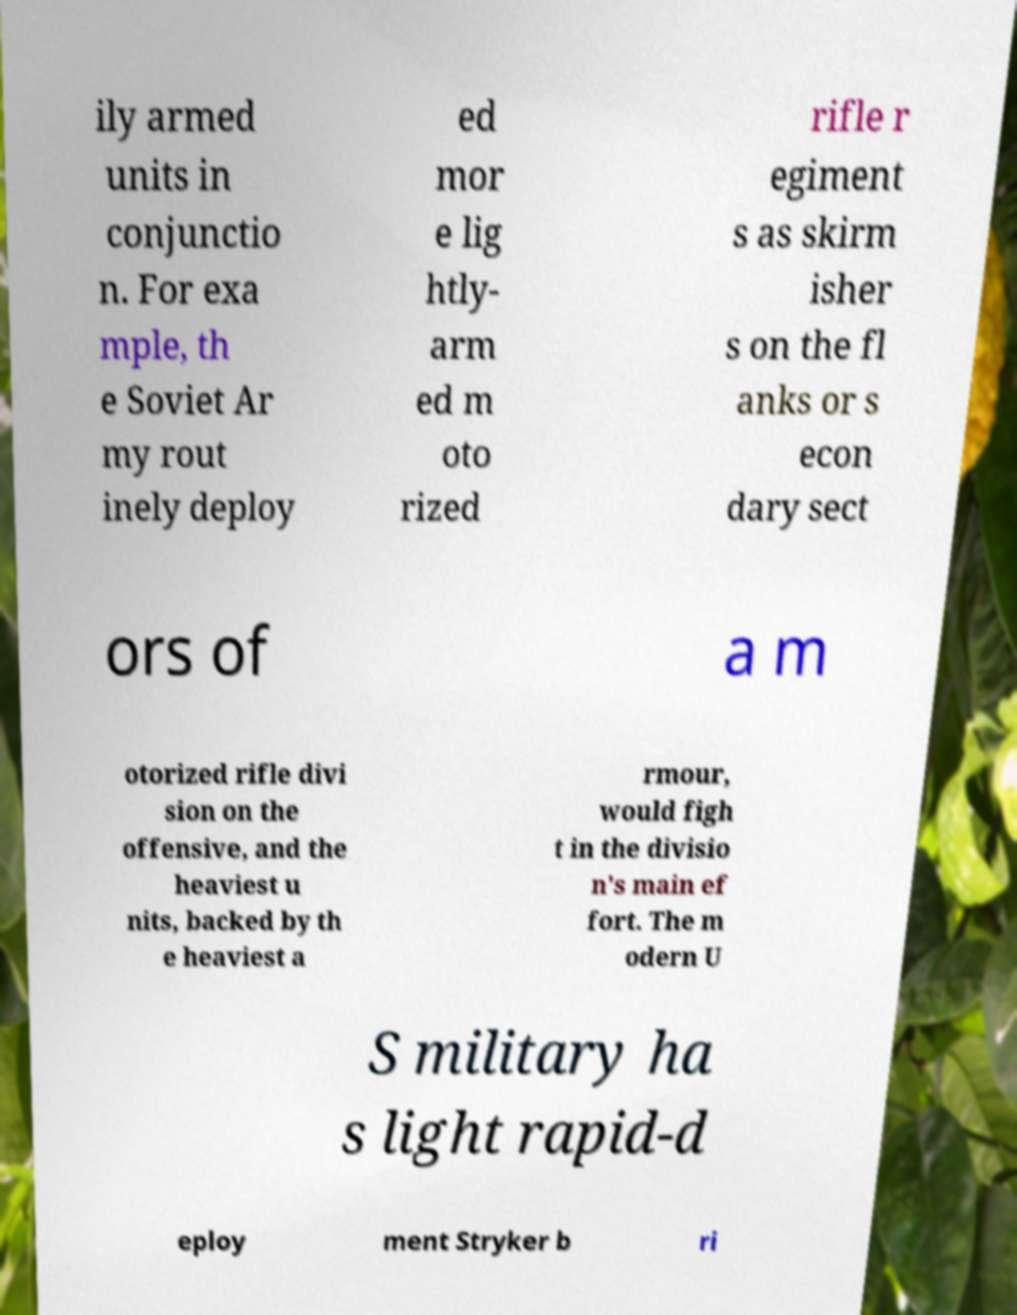Could you assist in decoding the text presented in this image and type it out clearly? ily armed units in conjunctio n. For exa mple, th e Soviet Ar my rout inely deploy ed mor e lig htly- arm ed m oto rized rifle r egiment s as skirm isher s on the fl anks or s econ dary sect ors of a m otorized rifle divi sion on the offensive, and the heaviest u nits, backed by th e heaviest a rmour, would figh t in the divisio n's main ef fort. The m odern U S military ha s light rapid-d eploy ment Stryker b ri 